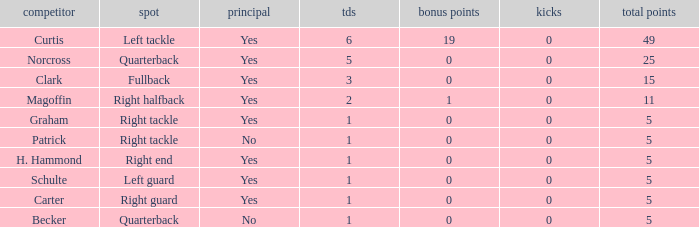Name the most touchdowns for norcross 5.0. 